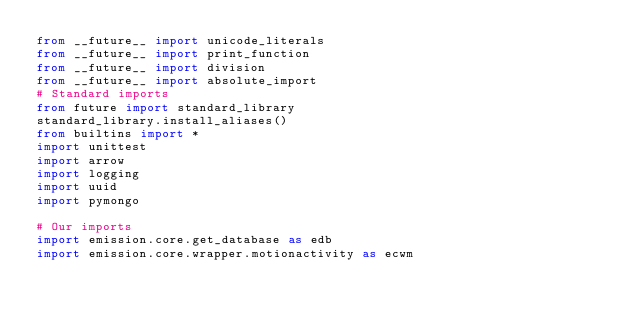Convert code to text. <code><loc_0><loc_0><loc_500><loc_500><_Python_>from __future__ import unicode_literals
from __future__ import print_function
from __future__ import division
from __future__ import absolute_import
# Standard imports
from future import standard_library
standard_library.install_aliases()
from builtins import *
import unittest
import arrow
import logging
import uuid
import pymongo

# Our imports
import emission.core.get_database as edb
import emission.core.wrapper.motionactivity as ecwm</code> 